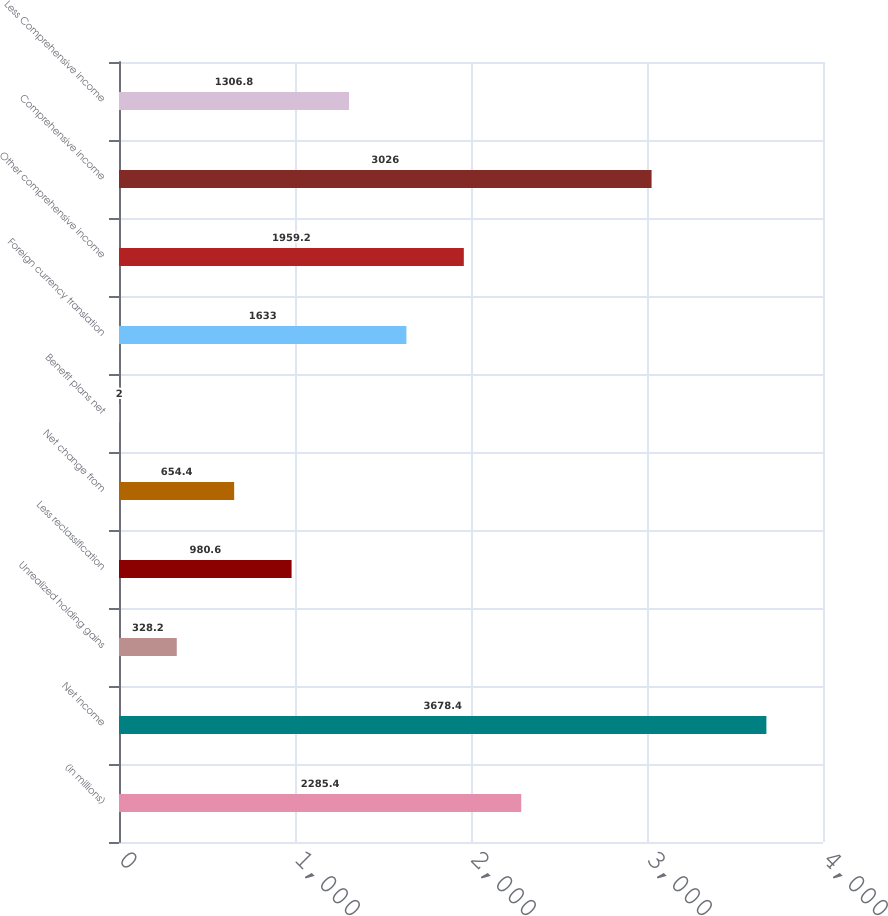Convert chart to OTSL. <chart><loc_0><loc_0><loc_500><loc_500><bar_chart><fcel>(in millions)<fcel>Net income<fcel>Unrealized holding gains<fcel>Less reclassification<fcel>Net change from<fcel>Benefit plans net<fcel>Foreign currency translation<fcel>Other comprehensive income<fcel>Comprehensive income<fcel>Less Comprehensive income<nl><fcel>2285.4<fcel>3678.4<fcel>328.2<fcel>980.6<fcel>654.4<fcel>2<fcel>1633<fcel>1959.2<fcel>3026<fcel>1306.8<nl></chart> 